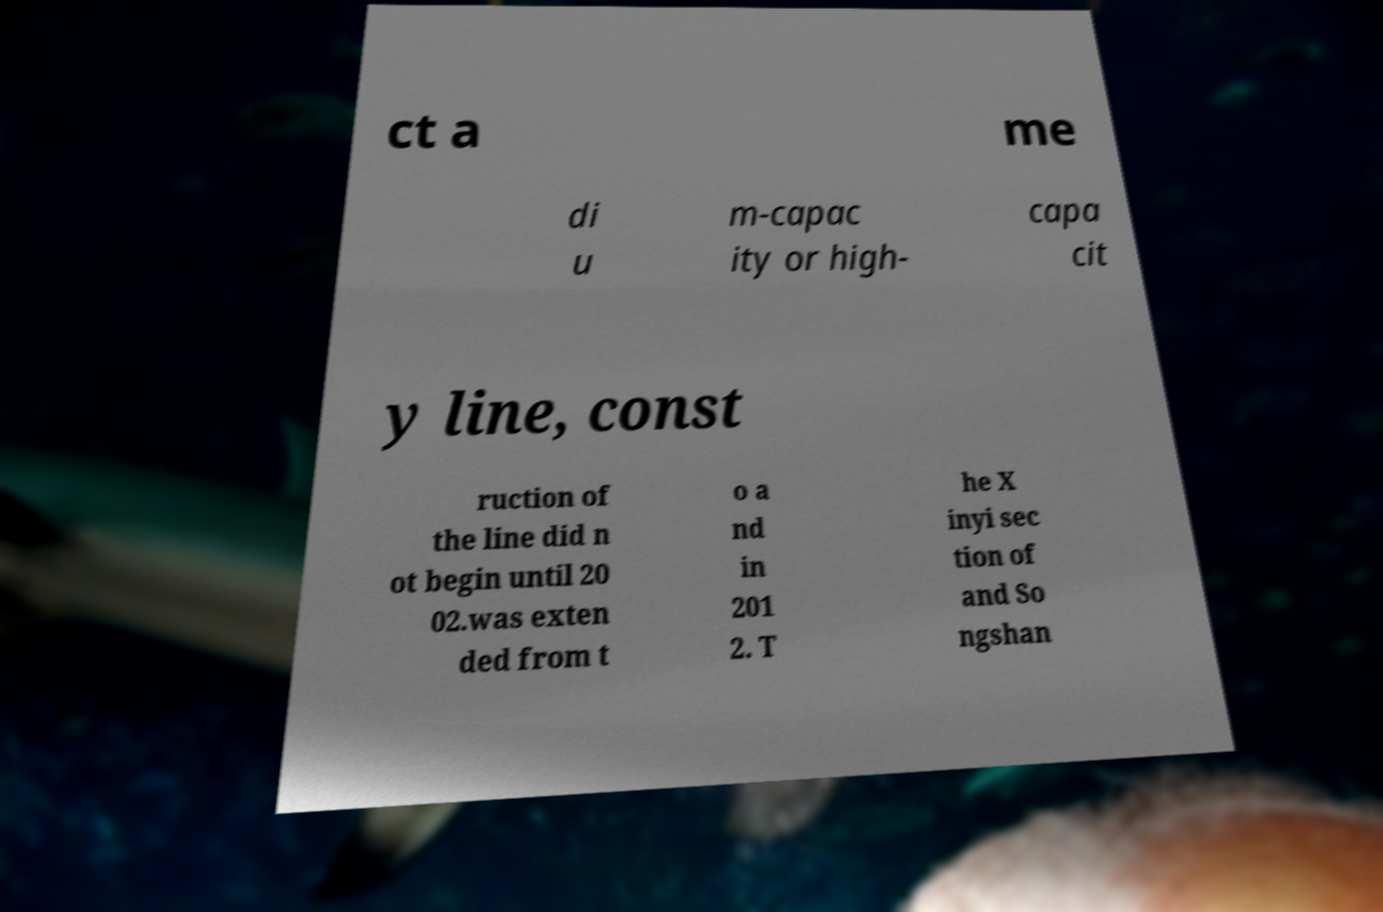There's text embedded in this image that I need extracted. Can you transcribe it verbatim? ct a me di u m-capac ity or high- capa cit y line, const ruction of the line did n ot begin until 20 02.was exten ded from t o a nd in 201 2. T he X inyi sec tion of and So ngshan 